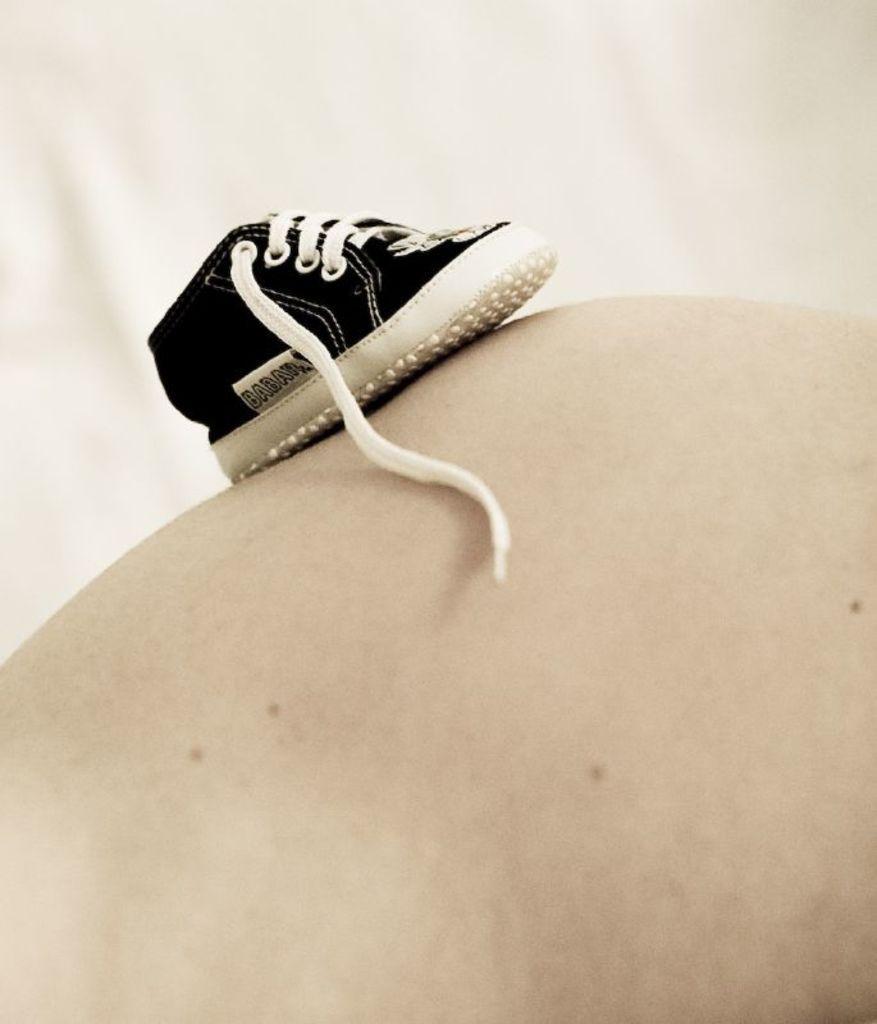Describe this image in one or two sentences. In this image we can see a shoe. There is a white background in the image. 